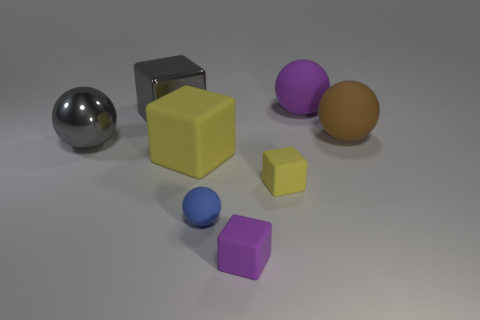Add 1 small yellow cubes. How many objects exist? 9 Subtract all brown blocks. Subtract all cyan balls. How many blocks are left? 4 Add 4 big rubber blocks. How many big rubber blocks are left? 5 Add 6 tiny purple blocks. How many tiny purple blocks exist? 7 Subtract 0 yellow balls. How many objects are left? 8 Subtract all large green metallic cubes. Subtract all gray metallic blocks. How many objects are left? 7 